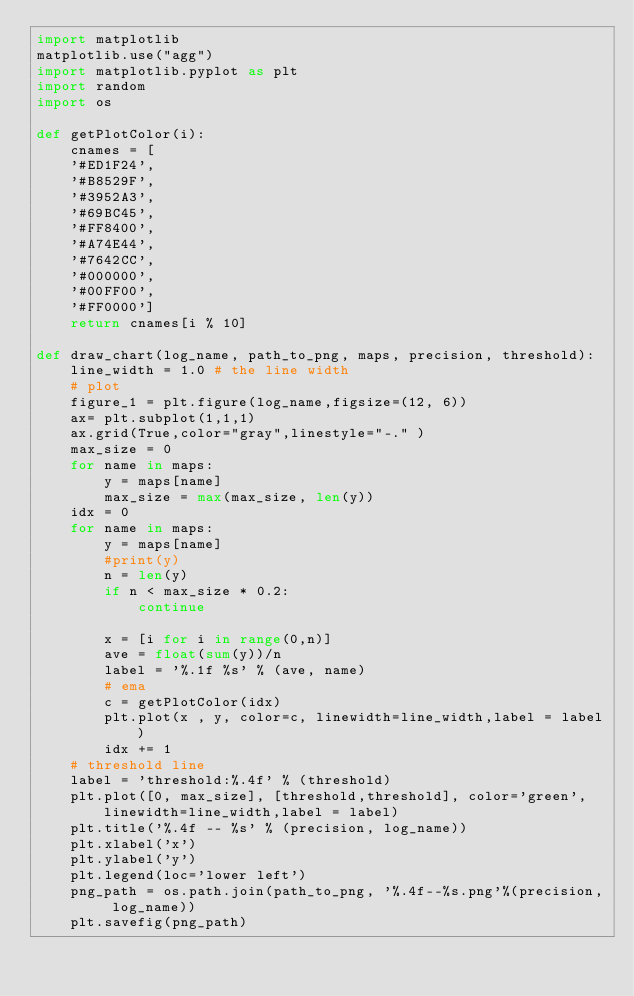<code> <loc_0><loc_0><loc_500><loc_500><_Python_>import matplotlib
matplotlib.use("agg")
import matplotlib.pyplot as plt
import random
import os

def getPlotColor(i):
    cnames = [
    '#ED1F24',
    '#B8529F',
    '#3952A3',
    '#69BC45', 
    '#FF8400',
    '#A74E44', 
    '#7642CC', 
    '#000000', 
    '#00FF00',
    '#FF0000']
    return cnames[i % 10]
    
def draw_chart(log_name, path_to_png, maps, precision, threshold):
    line_width = 1.0 # the line width
    # plot 
    figure_1 = plt.figure(log_name,figsize=(12, 6))
    ax= plt.subplot(1,1,1)
    ax.grid(True,color="gray",linestyle="-." )
    max_size = 0
    for name in maps:
        y = maps[name]
        max_size = max(max_size, len(y))
    idx = 0    
    for name in maps:
        y = maps[name]
        #print(y)
        n = len(y)
        if n < max_size * 0.2:
            continue
            
        x = [i for i in range(0,n)]
        ave = float(sum(y))/n
        label = '%.1f %s' % (ave, name)
        # ema 
        c = getPlotColor(idx)
        plt.plot(x , y, color=c, linewidth=line_width,label = label)
        idx += 1
    # threshold line
    label = 'threshold:%.4f' % (threshold)
    plt.plot([0, max_size], [threshold,threshold], color='green', linewidth=line_width,label = label)    
    plt.title('%.4f -- %s' % (precision, log_name))
    plt.xlabel('x')
    plt.ylabel('y')
    plt.legend(loc='lower left')
    png_path = os.path.join(path_to_png, '%.4f--%s.png'%(precision, log_name))
    plt.savefig(png_path)
</code> 